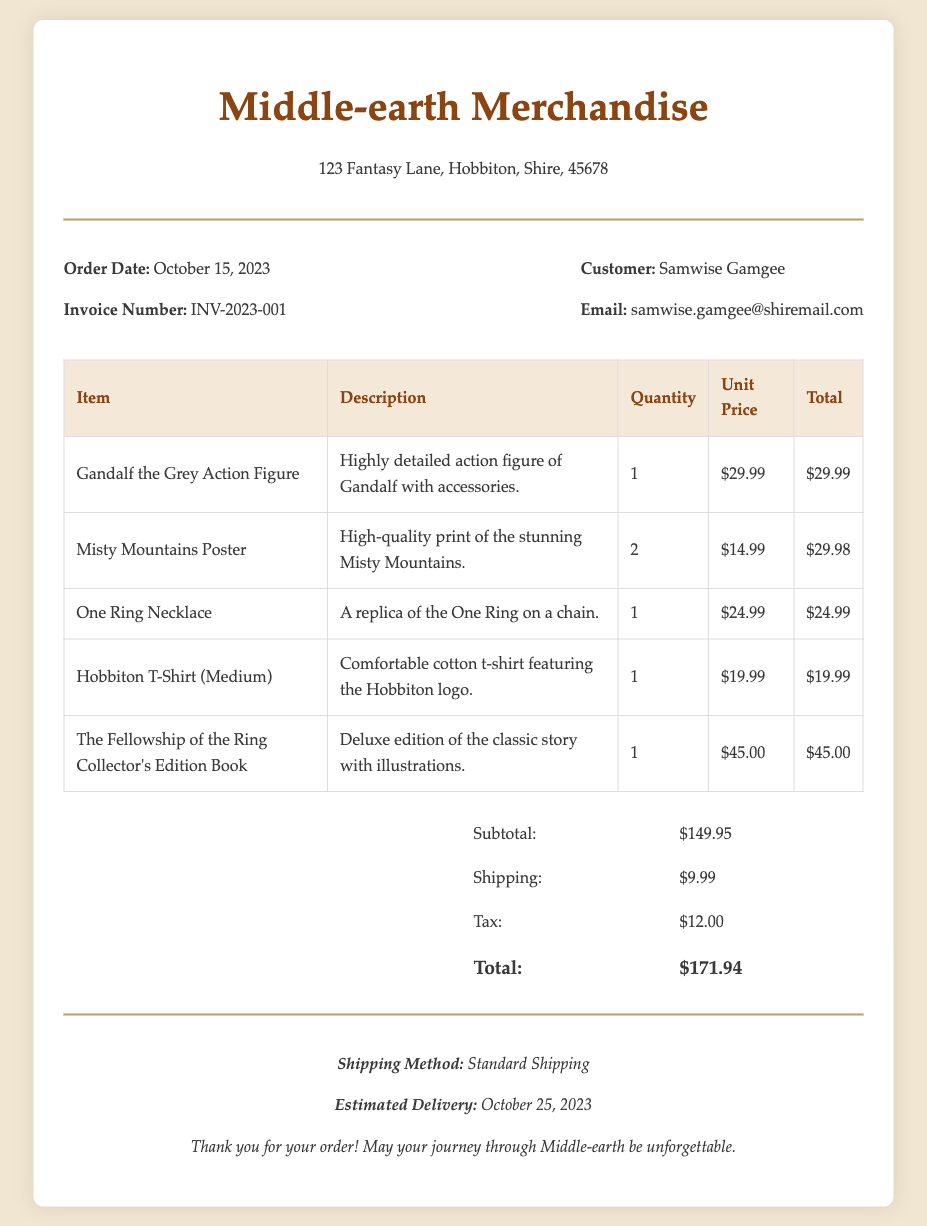What is the order date? The order date is specified in the document as the date when the order was placed, which is October 15, 2023.
Answer: October 15, 2023 What is the invoice number? The invoice number is a unique identifier for the order, which is provided in the document as INV-2023-001.
Answer: INV-2023-001 Who is the customer? The customer name is mentioned in the document as Samwise Gamgee, detailing the person who made the purchase.
Answer: Samwise Gamgee What is the total cost of the order? The total cost is the cumulative amount of all items, shipping, and tax, as stated in the summary section, which sums up to $171.94.
Answer: $171.94 How many Misty Mountains Posters were ordered? The quantity of Misty Mountains Posters can be retrieved from the items table, which shows 2 were ordered.
Answer: 2 What shipping method is used for the order? The shipping method is noted in the footer section, indicating how the goods will be delivered. Here, it is stated as Standard Shipping.
Answer: Standard Shipping What item has the highest unit price? To find this, we compare the unit prices listed in the items table. The item with the highest unit price is The Fellowship of the Ring Collector's Edition Book at $45.00.
Answer: The Fellowship of the Ring Collector's Edition Book What is the estimated delivery date? The estimated delivery date is mentioned in the footer of the document, providing customers with a timeframe for when to expect their order. It is stated as October 25, 2023.
Answer: October 25, 2023 What is the subtotal amount before shipping and tax? The subtotal is the total of all item costs listed in the items table before shipping and tax are added, which is shown as $149.95.
Answer: $149.95 